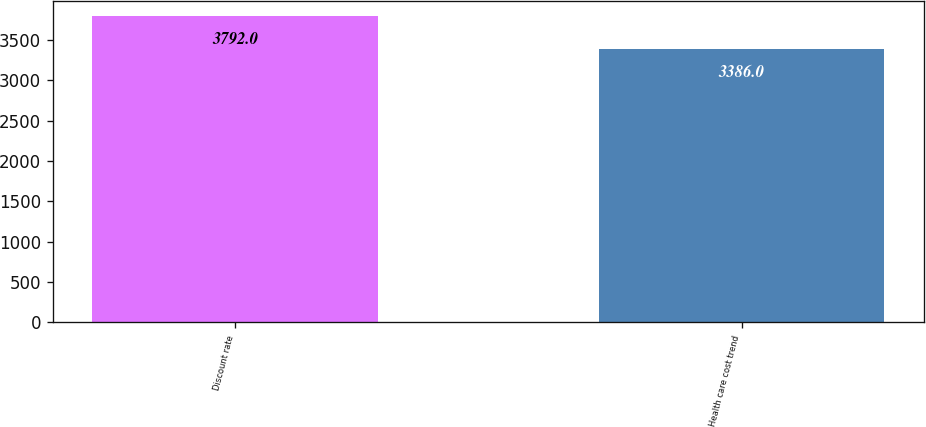Convert chart to OTSL. <chart><loc_0><loc_0><loc_500><loc_500><bar_chart><fcel>Discount rate<fcel>Health care cost trend<nl><fcel>3792<fcel>3386<nl></chart> 